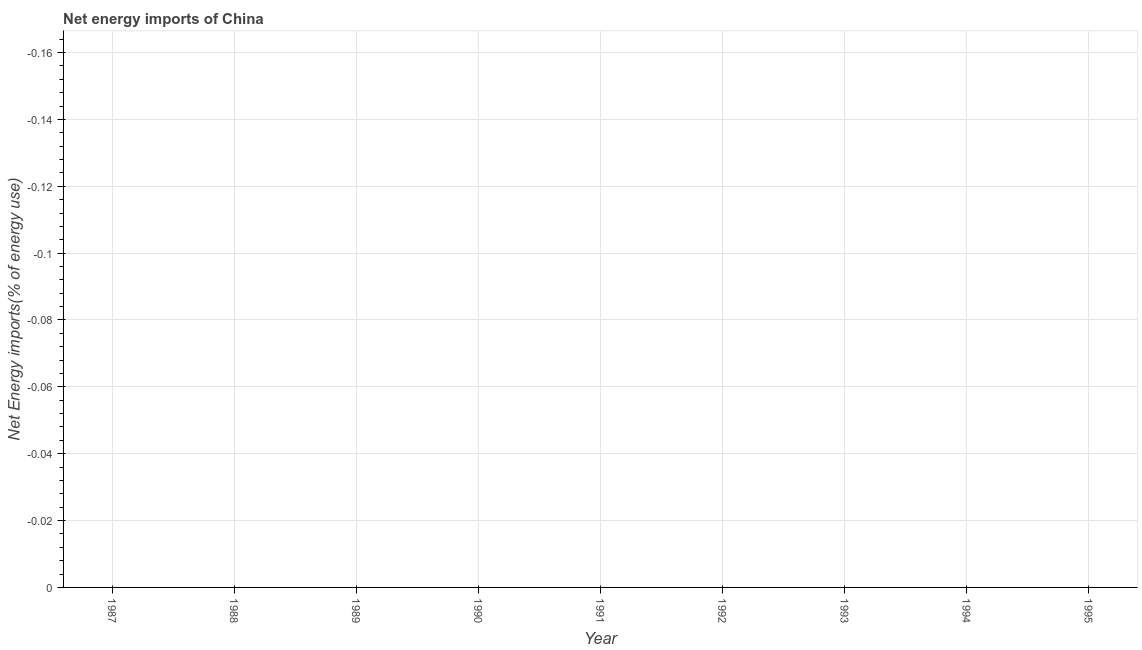What is the energy imports in 1991?
Your answer should be very brief. 0. What is the average energy imports per year?
Your answer should be compact. 0. What is the median energy imports?
Ensure brevity in your answer.  0. In how many years, is the energy imports greater than -0.008 %?
Your response must be concise. 0. Does the energy imports monotonically increase over the years?
Ensure brevity in your answer.  No. How many years are there in the graph?
Ensure brevity in your answer.  9. What is the difference between two consecutive major ticks on the Y-axis?
Your answer should be compact. 0.02. What is the title of the graph?
Provide a short and direct response. Net energy imports of China. What is the label or title of the Y-axis?
Your answer should be compact. Net Energy imports(% of energy use). What is the Net Energy imports(% of energy use) of 1988?
Keep it short and to the point. 0. What is the Net Energy imports(% of energy use) in 1991?
Offer a terse response. 0. What is the Net Energy imports(% of energy use) in 1993?
Make the answer very short. 0. What is the Net Energy imports(% of energy use) of 1994?
Offer a very short reply. 0. 